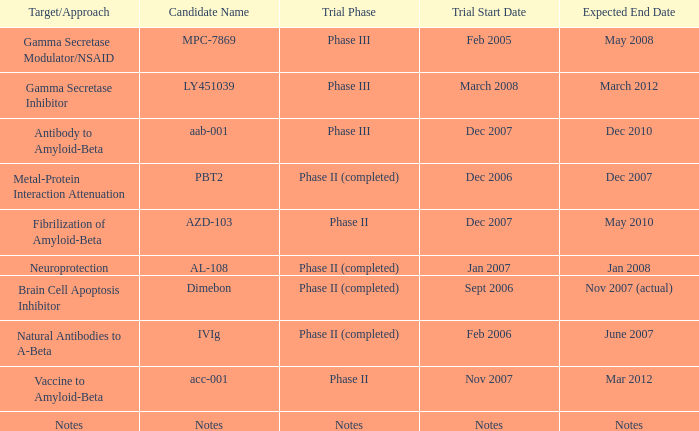When the trial start date is nov 2007, what is the anticipated end date? Mar 2012. 